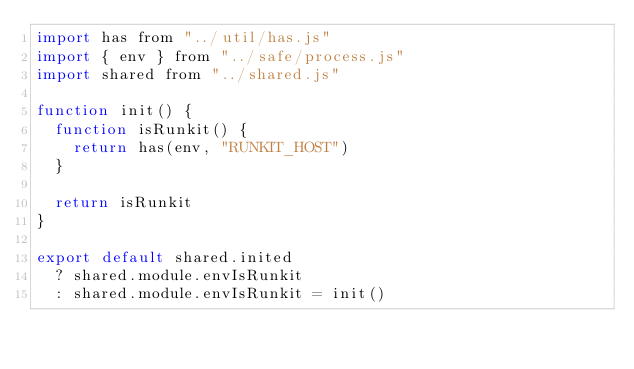<code> <loc_0><loc_0><loc_500><loc_500><_JavaScript_>import has from "../util/has.js"
import { env } from "../safe/process.js"
import shared from "../shared.js"

function init() {
  function isRunkit() {
    return has(env, "RUNKIT_HOST")
  }

  return isRunkit
}

export default shared.inited
  ? shared.module.envIsRunkit
  : shared.module.envIsRunkit = init()
</code> 